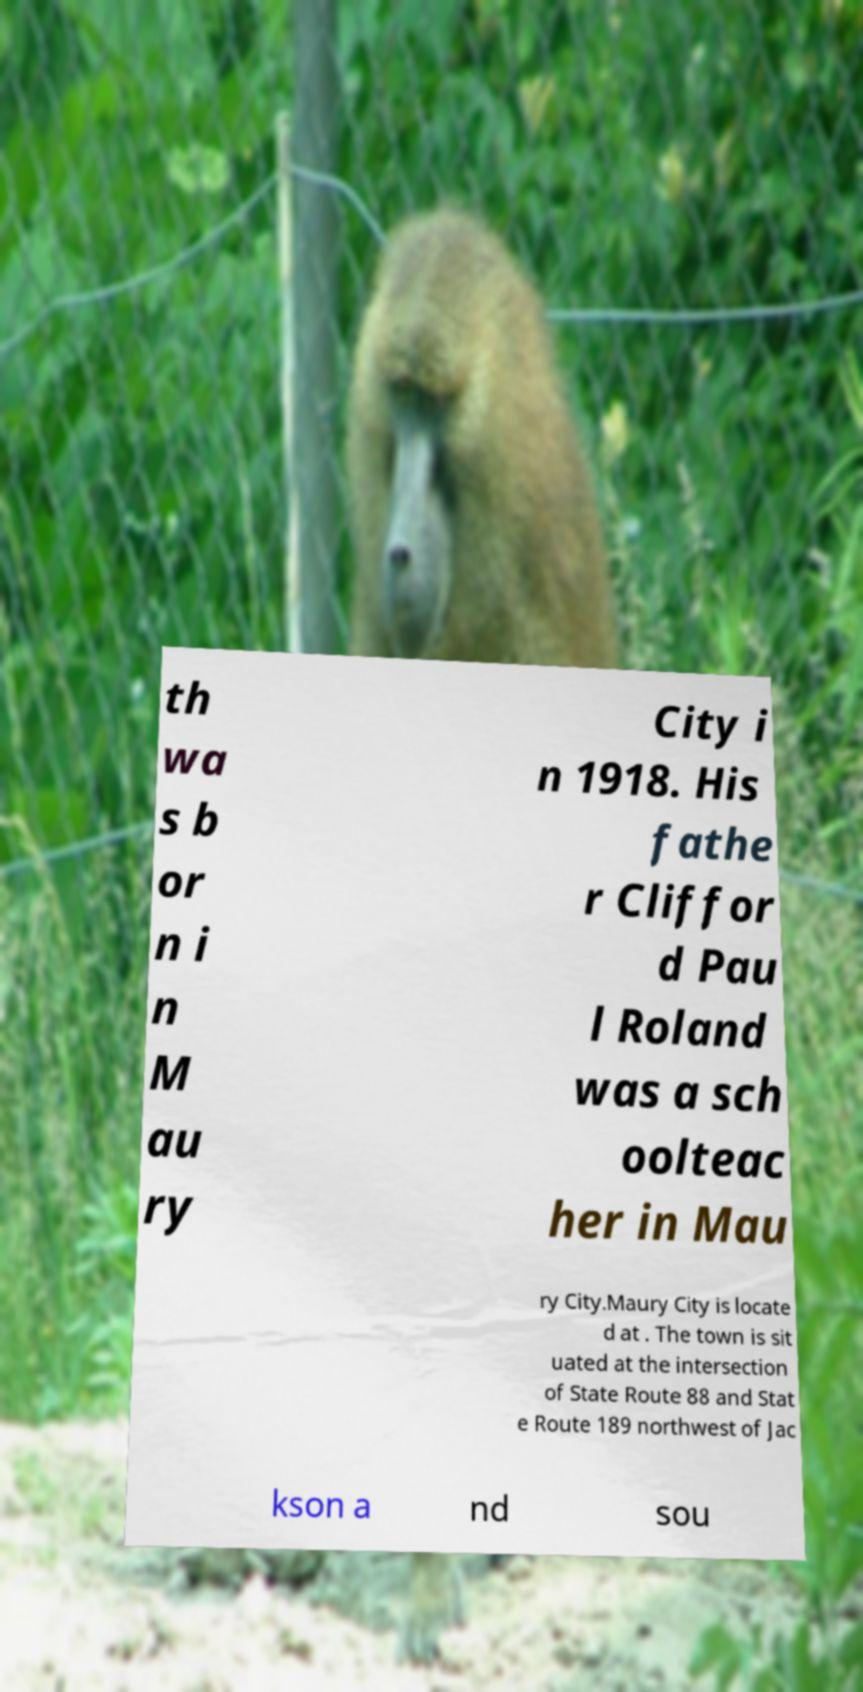What messages or text are displayed in this image? I need them in a readable, typed format. th wa s b or n i n M au ry City i n 1918. His fathe r Cliffor d Pau l Roland was a sch oolteac her in Mau ry City.Maury City is locate d at . The town is sit uated at the intersection of State Route 88 and Stat e Route 189 northwest of Jac kson a nd sou 